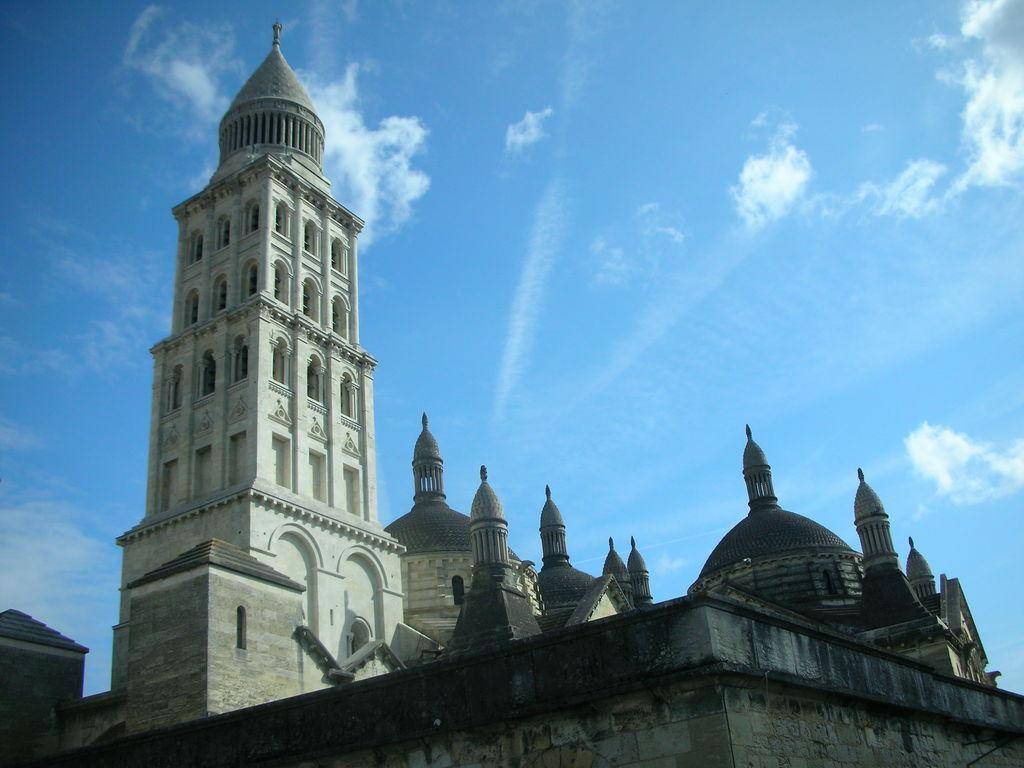What is located in the foreground of the image? There is a wall in the foreground of the image. What type of structure can be seen in the image? There is a tall building in the image. What can be seen in the sky in the image? There are clouds visible in the sky. How many tomatoes are hanging from the wall in the image? There are no tomatoes present in the image; it features a wall, a tall building, and clouds in the sky. What type of brake is visible on the tall building in the image? There is no brake visible on the tall building in the image. 